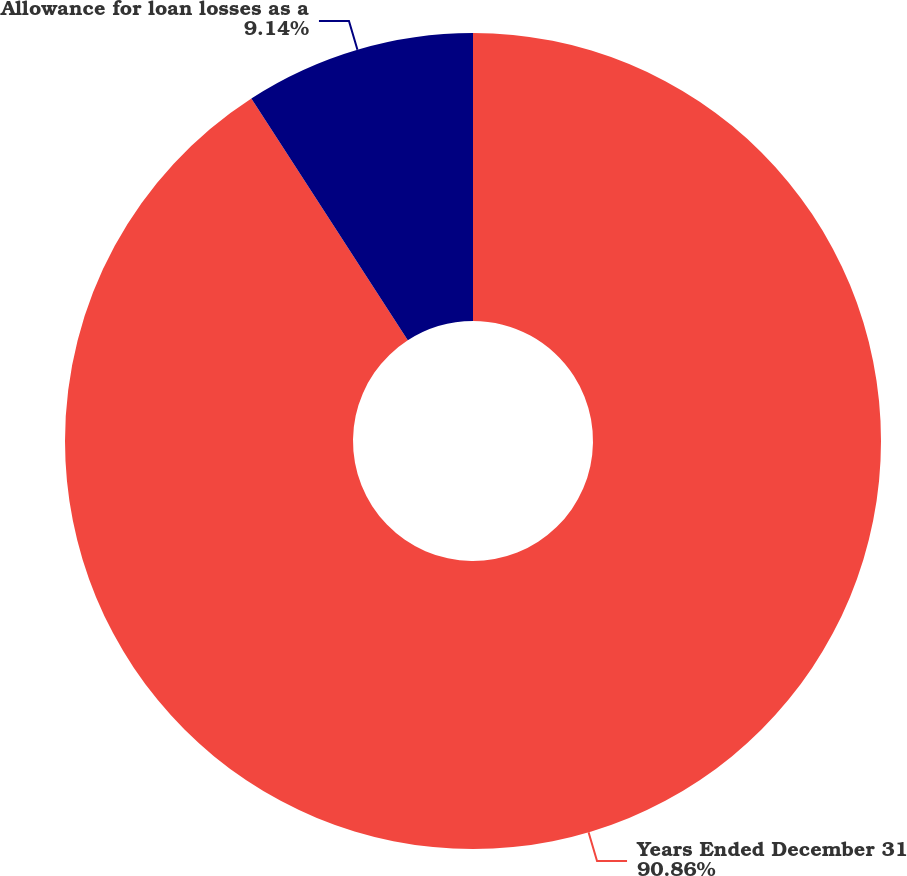<chart> <loc_0><loc_0><loc_500><loc_500><pie_chart><fcel>Years Ended December 31<fcel>Allowance for loan losses as a<nl><fcel>90.86%<fcel>9.14%<nl></chart> 